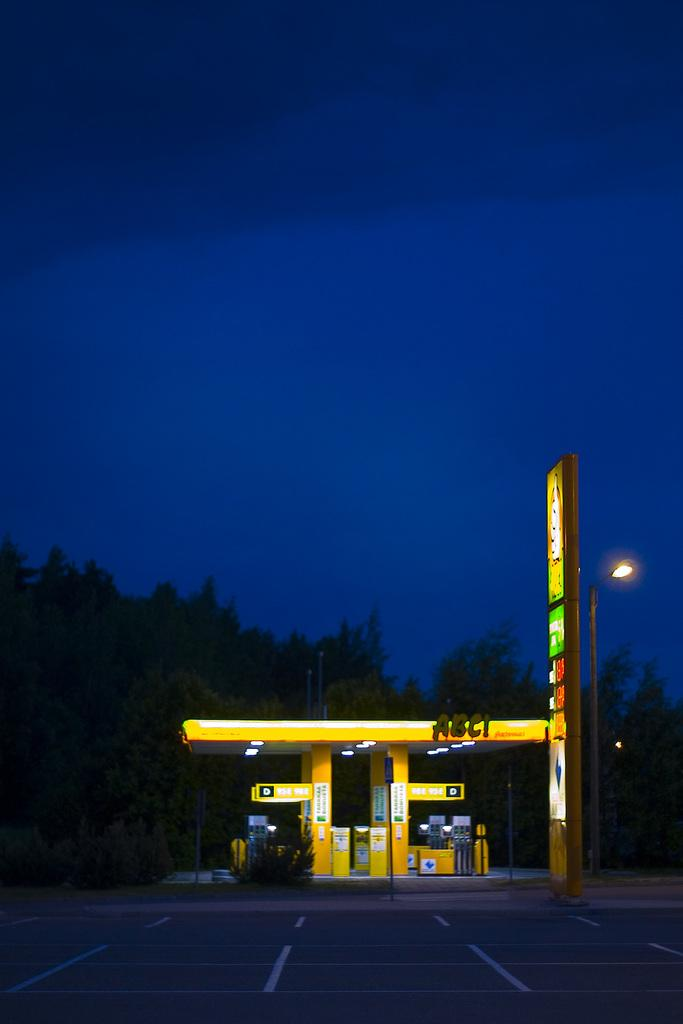<image>
Relay a brief, clear account of the picture shown. A yellow ABC! Service Station with a sign at the entrance 